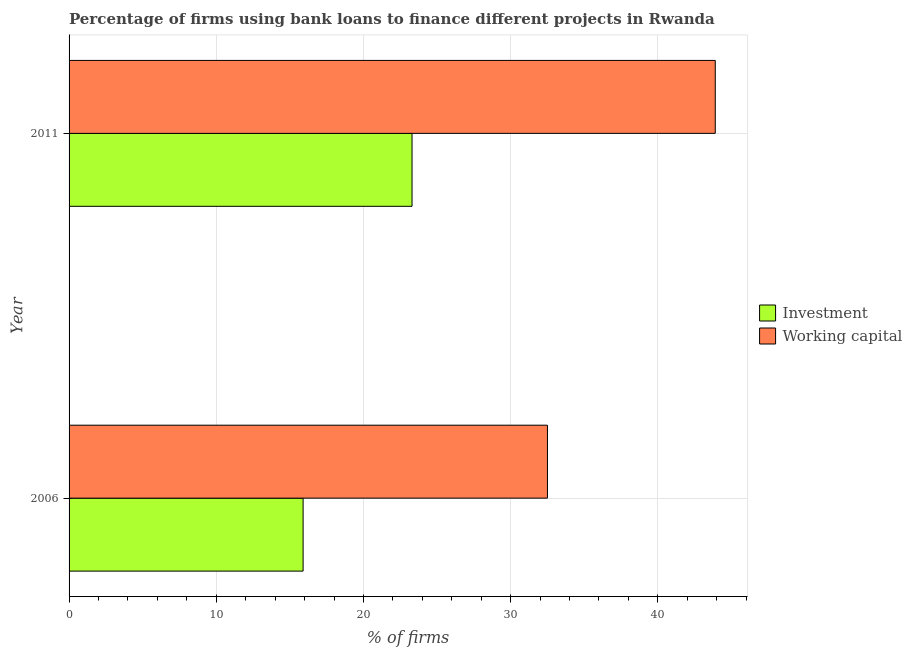How many different coloured bars are there?
Ensure brevity in your answer.  2. How many groups of bars are there?
Give a very brief answer. 2. Are the number of bars per tick equal to the number of legend labels?
Provide a succinct answer. Yes. How many bars are there on the 2nd tick from the top?
Provide a short and direct response. 2. How many bars are there on the 1st tick from the bottom?
Offer a terse response. 2. What is the label of the 2nd group of bars from the top?
Your answer should be very brief. 2006. In how many cases, is the number of bars for a given year not equal to the number of legend labels?
Give a very brief answer. 0. What is the percentage of firms using banks to finance investment in 2011?
Keep it short and to the point. 23.3. Across all years, what is the maximum percentage of firms using banks to finance investment?
Give a very brief answer. 23.3. Across all years, what is the minimum percentage of firms using banks to finance working capital?
Keep it short and to the point. 32.5. In which year was the percentage of firms using banks to finance working capital maximum?
Your answer should be compact. 2011. What is the total percentage of firms using banks to finance investment in the graph?
Your answer should be compact. 39.2. What is the difference between the percentage of firms using banks to finance investment in 2006 and that in 2011?
Provide a short and direct response. -7.4. What is the average percentage of firms using banks to finance investment per year?
Give a very brief answer. 19.6. In the year 2011, what is the difference between the percentage of firms using banks to finance working capital and percentage of firms using banks to finance investment?
Offer a terse response. 20.6. In how many years, is the percentage of firms using banks to finance investment greater than 12 %?
Provide a succinct answer. 2. What is the ratio of the percentage of firms using banks to finance working capital in 2006 to that in 2011?
Ensure brevity in your answer.  0.74. Is the percentage of firms using banks to finance working capital in 2006 less than that in 2011?
Your response must be concise. Yes. In how many years, is the percentage of firms using banks to finance investment greater than the average percentage of firms using banks to finance investment taken over all years?
Offer a terse response. 1. What does the 1st bar from the top in 2006 represents?
Keep it short and to the point. Working capital. What does the 1st bar from the bottom in 2011 represents?
Your response must be concise. Investment. How many bars are there?
Give a very brief answer. 4. Are all the bars in the graph horizontal?
Your answer should be very brief. Yes. How many years are there in the graph?
Offer a terse response. 2. Are the values on the major ticks of X-axis written in scientific E-notation?
Offer a very short reply. No. What is the title of the graph?
Make the answer very short. Percentage of firms using bank loans to finance different projects in Rwanda. Does "Male" appear as one of the legend labels in the graph?
Your response must be concise. No. What is the label or title of the X-axis?
Your response must be concise. % of firms. What is the label or title of the Y-axis?
Your response must be concise. Year. What is the % of firms in Investment in 2006?
Provide a short and direct response. 15.9. What is the % of firms in Working capital in 2006?
Your answer should be compact. 32.5. What is the % of firms in Investment in 2011?
Offer a very short reply. 23.3. What is the % of firms in Working capital in 2011?
Provide a succinct answer. 43.9. Across all years, what is the maximum % of firms of Investment?
Your answer should be very brief. 23.3. Across all years, what is the maximum % of firms in Working capital?
Provide a succinct answer. 43.9. Across all years, what is the minimum % of firms of Working capital?
Offer a very short reply. 32.5. What is the total % of firms in Investment in the graph?
Ensure brevity in your answer.  39.2. What is the total % of firms of Working capital in the graph?
Ensure brevity in your answer.  76.4. What is the difference between the % of firms of Investment in 2006 and that in 2011?
Offer a very short reply. -7.4. What is the difference between the % of firms of Working capital in 2006 and that in 2011?
Your answer should be very brief. -11.4. What is the average % of firms of Investment per year?
Your response must be concise. 19.6. What is the average % of firms in Working capital per year?
Offer a very short reply. 38.2. In the year 2006, what is the difference between the % of firms in Investment and % of firms in Working capital?
Ensure brevity in your answer.  -16.6. In the year 2011, what is the difference between the % of firms in Investment and % of firms in Working capital?
Offer a very short reply. -20.6. What is the ratio of the % of firms in Investment in 2006 to that in 2011?
Give a very brief answer. 0.68. What is the ratio of the % of firms in Working capital in 2006 to that in 2011?
Your answer should be compact. 0.74. What is the difference between the highest and the second highest % of firms of Investment?
Keep it short and to the point. 7.4. What is the difference between the highest and the lowest % of firms in Working capital?
Your answer should be compact. 11.4. 